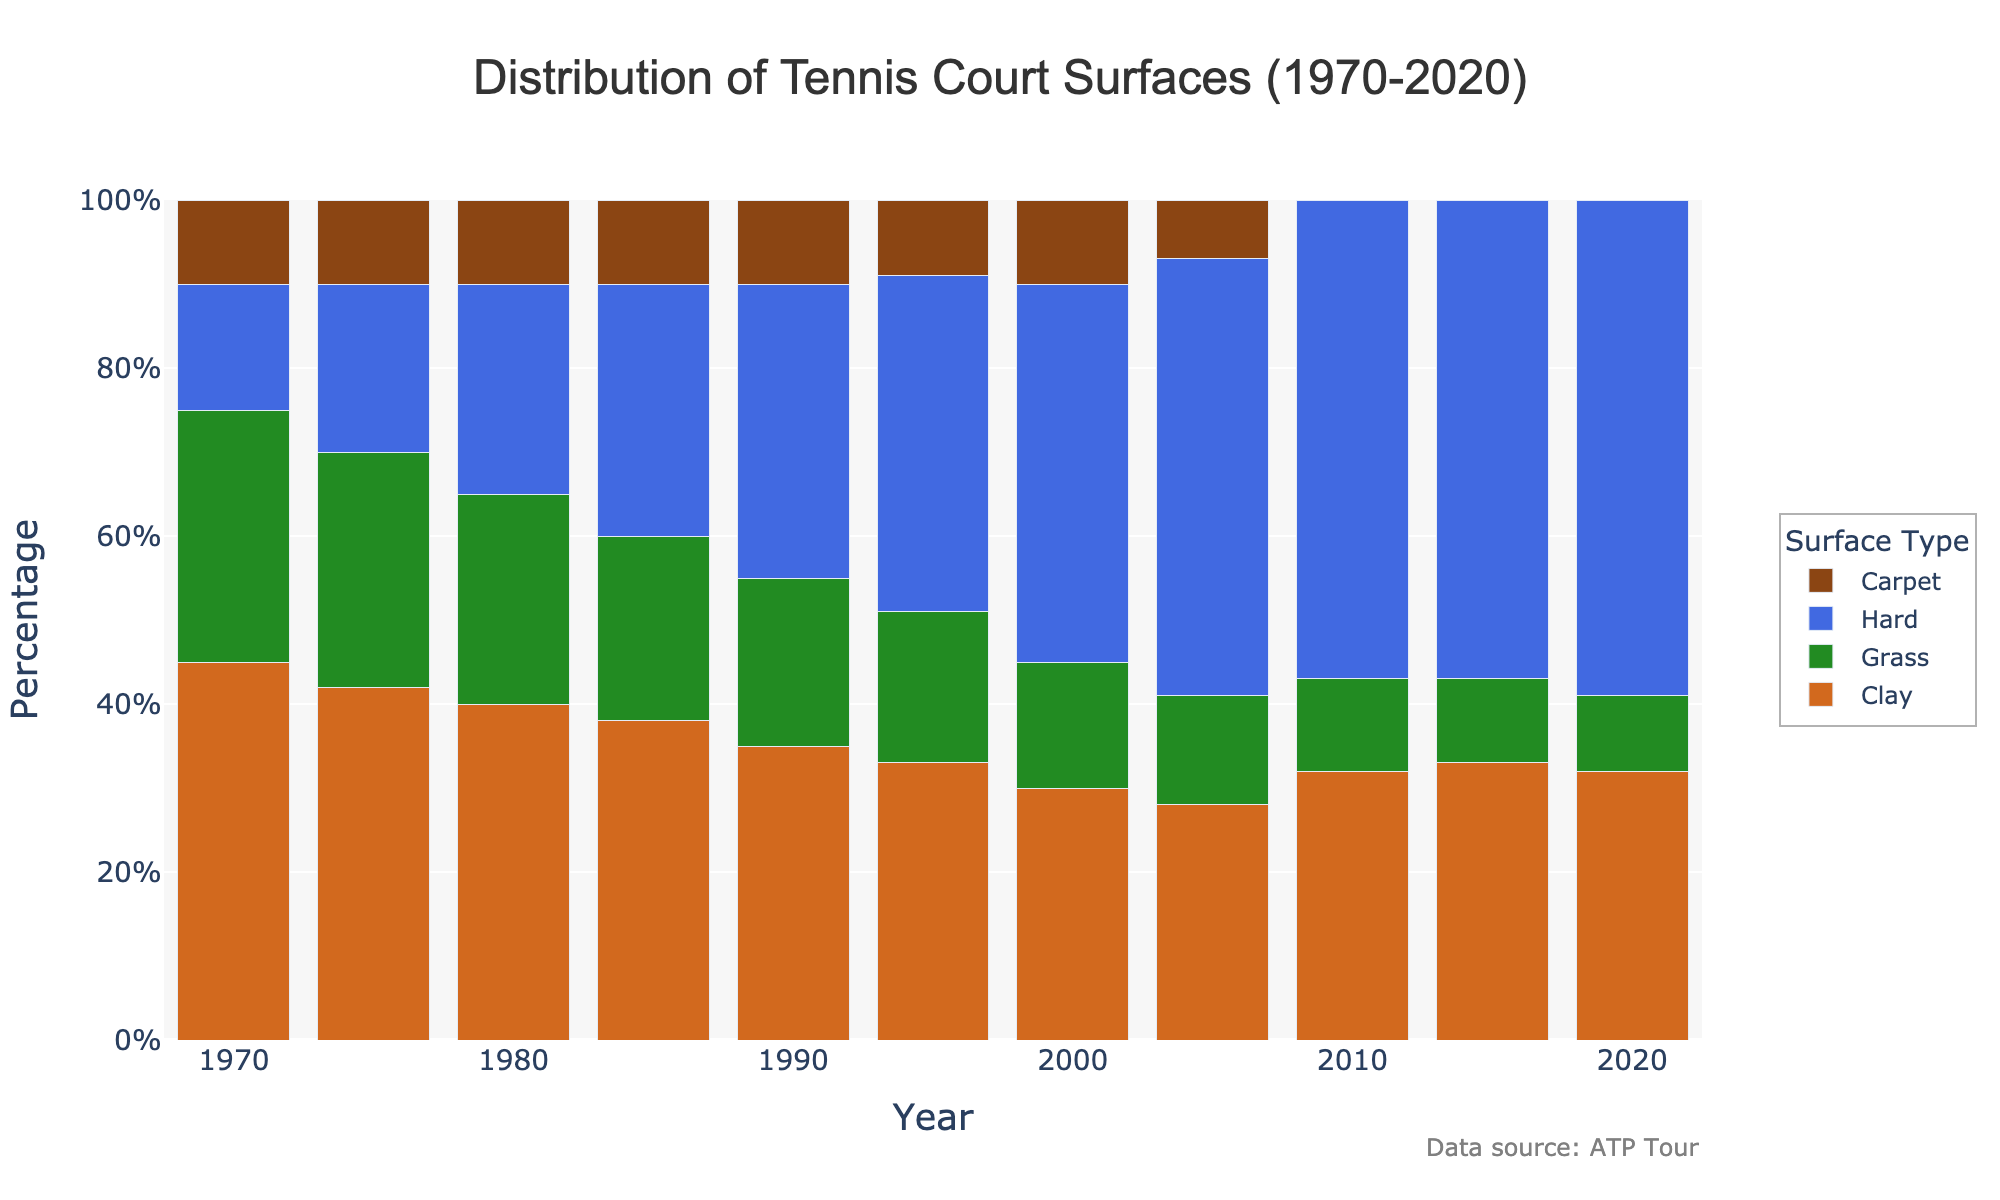How has the percentage of clay courts changed from 1970 to 2020? To find the change, compare the percentage of clay courts in 1970 and 2020. In 1970, clay courts accounted for 45%. In 2020, it was 32%. The change is 45% - 32% = 13%.
Answer: Decreased by 13% Which surface type saw the most significant increase from 1970 to 2020? Compare the percentage increase for each surface type between 1970 and 2020. Clay decreased by 13%, Grass decreased by 21%, Hard increased by 44%, and Carpet, which was 10% in 1970, is 0% in 2020, thus it fully decreased. Hard courts increased the most.
Answer: Hard courts Between which decades did grass courts see the most significant drop in percentage? Look for the decade with the highest decrease in grass court percentage. From 1970 to 1980, Grass courts dropped 30% to 25% (5%). From 1980 to 1990, it dropped 25% to 20% (5%). From 1990 to 2000, it dropped 20% to 15% (5%). From 2000 to 2020, it decreased 15% to 9% (6%). Hence, from 2000 to 2020 shows the most significant drop, specifically 2000 to 2005.
Answer: 2000 to 2005 Which surface was the second most common in 1995? Look at the percentages in 1995. Clay was 33%, Grass was 18%, Hard was 40%, and Carpet was 9%. The second highest percentage is for Clay courts.
Answer: Clay How many surface types were used in 1970 and continue to be used in 2020? Identify which surfaces had non-zero percentages in both 1970 and 2020. In 1970, all surfaces were used (Clay, Grass, Hard, and Carpet). By 2020, three were still in use (Clay, Grass, Hard), with Carpet no longer used (0%). The answer is the three surfaces.
Answer: Three What trend can be observed in the usage of carpet courts? Observe the percentages of carpet courts from 1970 to 2020: 10% in 1970, a steady usage until 2010 where it drops to 0%.
Answer: Decreasing to 0% By how much did the usage of hard courts increase between 1980 and 2010? Calculate the increase in percentage of hard courts from 1980 (25%) to 2010 (57%). 57% - 25% = 32%.
Answer: 32% In which year did hard courts surpass clay courts in percentage usage? Compare the percentages of clay and hard courts for each year until hard courts exceed clay courts. In 1985, hard courts (30%) were still behind clay (38%). By 1990, both were equal at 35%. By 1995, hard courts (40%) surpassed clay (33%).
Answer: 1995 